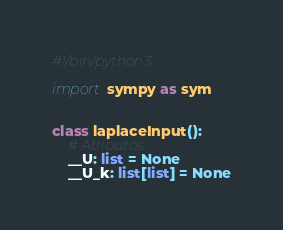<code> <loc_0><loc_0><loc_500><loc_500><_Python_>#!/bin/python3

import sympy as sym


class laplaceInput():
    # Atributos
    __U: list = None
    __U_k: list[list] = None
</code> 